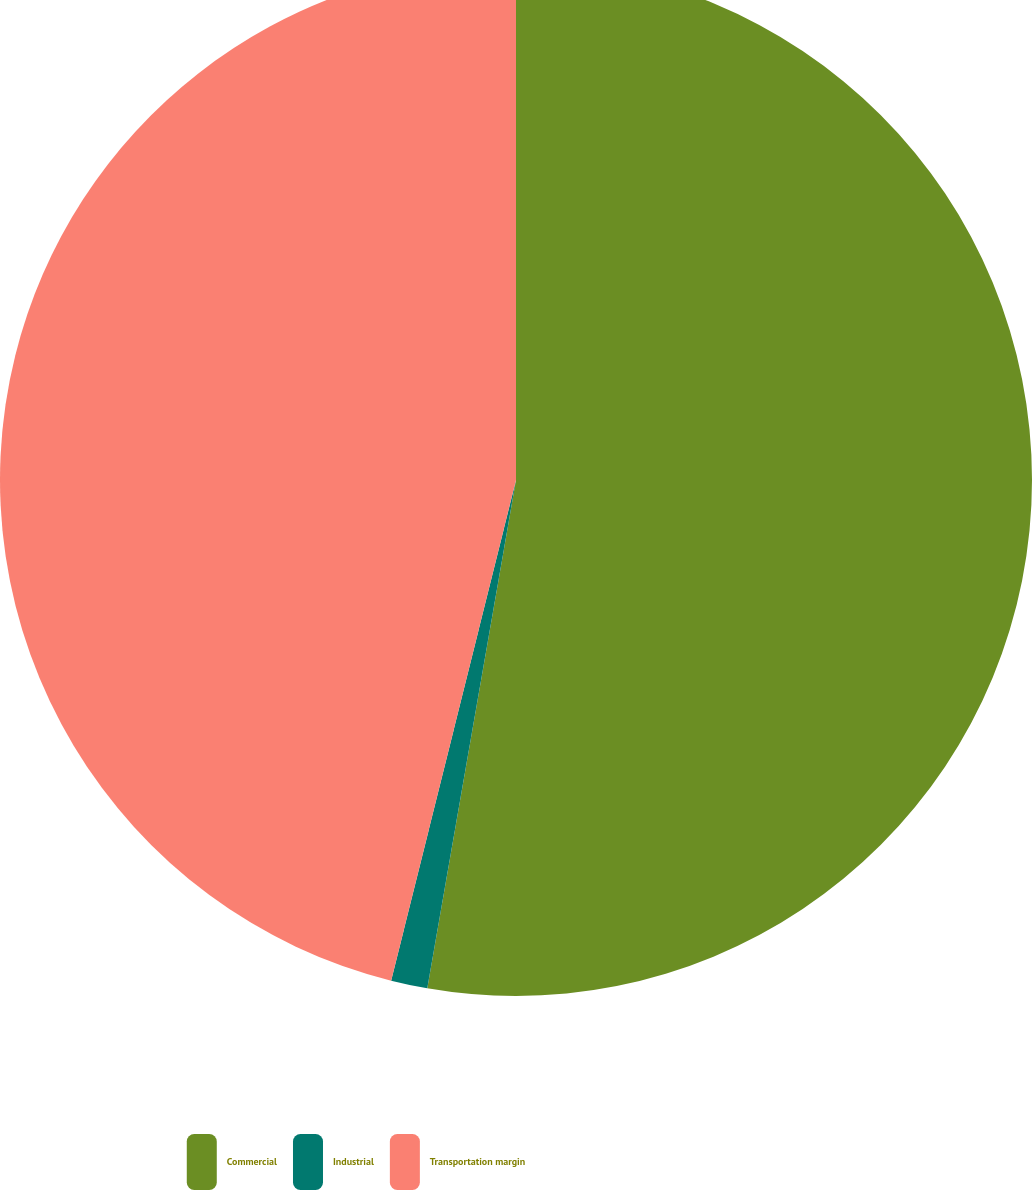<chart> <loc_0><loc_0><loc_500><loc_500><pie_chart><fcel>Commercial<fcel>Industrial<fcel>Transportation margin<nl><fcel>52.75%<fcel>1.14%<fcel>46.11%<nl></chart> 